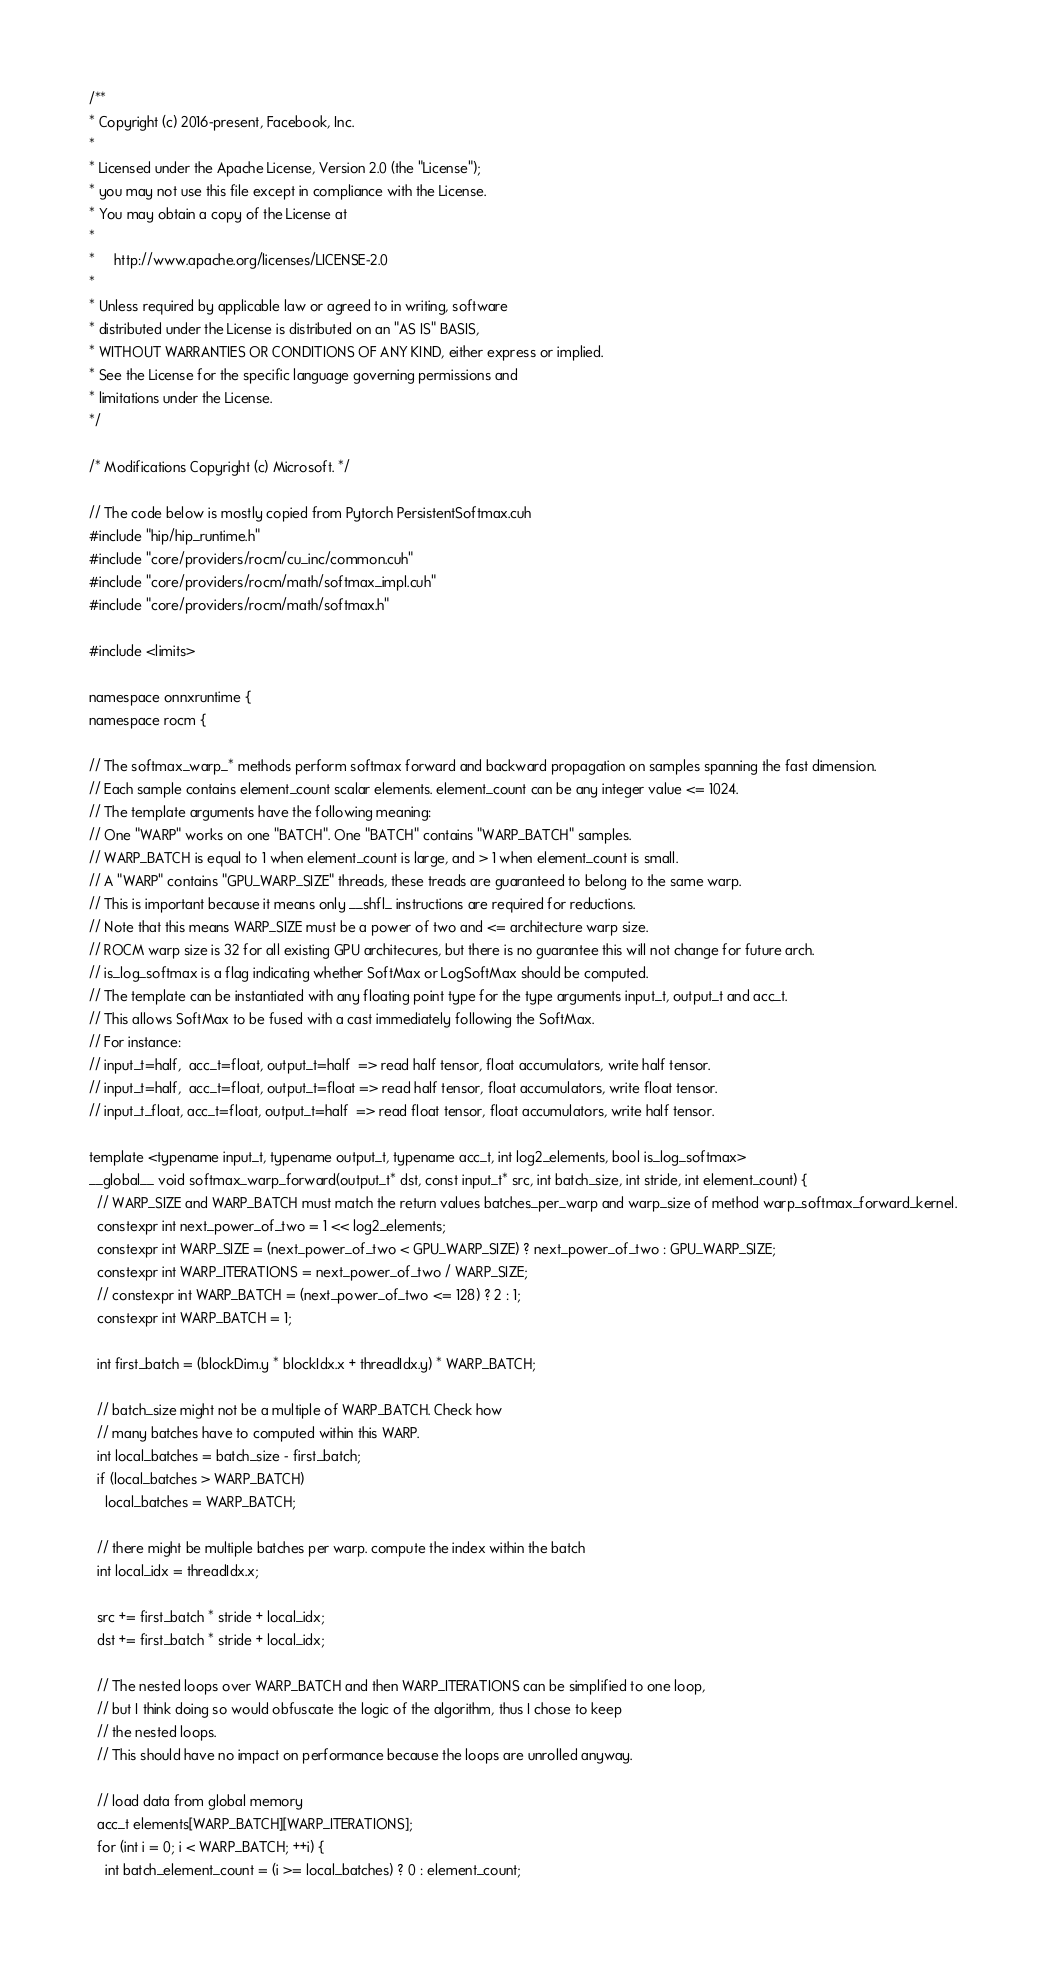<code> <loc_0><loc_0><loc_500><loc_500><_Cuda_>/**
* Copyright (c) 2016-present, Facebook, Inc.
*
* Licensed under the Apache License, Version 2.0 (the "License");
* you may not use this file except in compliance with the License.
* You may obtain a copy of the License at
*
*     http://www.apache.org/licenses/LICENSE-2.0
*
* Unless required by applicable law or agreed to in writing, software
* distributed under the License is distributed on an "AS IS" BASIS,
* WITHOUT WARRANTIES OR CONDITIONS OF ANY KIND, either express or implied.
* See the License for the specific language governing permissions and
* limitations under the License.
*/

/* Modifications Copyright (c) Microsoft. */

// The code below is mostly copied from Pytorch PersistentSoftmax.cuh
#include "hip/hip_runtime.h"
#include "core/providers/rocm/cu_inc/common.cuh"
#include "core/providers/rocm/math/softmax_impl.cuh"
#include "core/providers/rocm/math/softmax.h"

#include <limits>

namespace onnxruntime {
namespace rocm {

// The softmax_warp_* methods perform softmax forward and backward propagation on samples spanning the fast dimension.
// Each sample contains element_count scalar elements. element_count can be any integer value <= 1024.
// The template arguments have the following meaning:
// One "WARP" works on one "BATCH". One "BATCH" contains "WARP_BATCH" samples.
// WARP_BATCH is equal to 1 when element_count is large, and > 1 when element_count is small.
// A "WARP" contains "GPU_WARP_SIZE" threads, these treads are guaranteed to belong to the same warp.
// This is important because it means only __shfl_ instructions are required for reductions.
// Note that this means WARP_SIZE must be a power of two and <= architecture warp size.
// ROCM warp size is 32 for all existing GPU architecures, but there is no guarantee this will not change for future arch.
// is_log_softmax is a flag indicating whether SoftMax or LogSoftMax should be computed.
// The template can be instantiated with any floating point type for the type arguments input_t, output_t and acc_t.
// This allows SoftMax to be fused with a cast immediately following the SoftMax.
// For instance:
// input_t=half,  acc_t=float, output_t=half  => read half tensor, float accumulators, write half tensor.
// input_t=half,  acc_t=float, output_t=float => read half tensor, float accumulators, write float tensor.
// input_t_float, acc_t=float, output_t=half  => read float tensor, float accumulators, write half tensor.

template <typename input_t, typename output_t, typename acc_t, int log2_elements, bool is_log_softmax>
__global__ void softmax_warp_forward(output_t* dst, const input_t* src, int batch_size, int stride, int element_count) {
  // WARP_SIZE and WARP_BATCH must match the return values batches_per_warp and warp_size of method warp_softmax_forward_kernel.
  constexpr int next_power_of_two = 1 << log2_elements;
  constexpr int WARP_SIZE = (next_power_of_two < GPU_WARP_SIZE) ? next_power_of_two : GPU_WARP_SIZE;
  constexpr int WARP_ITERATIONS = next_power_of_two / WARP_SIZE;
  // constexpr int WARP_BATCH = (next_power_of_two <= 128) ? 2 : 1;
  constexpr int WARP_BATCH = 1;

  int first_batch = (blockDim.y * blockIdx.x + threadIdx.y) * WARP_BATCH;

  // batch_size might not be a multiple of WARP_BATCH. Check how
  // many batches have to computed within this WARP.
  int local_batches = batch_size - first_batch;
  if (local_batches > WARP_BATCH)
    local_batches = WARP_BATCH;

  // there might be multiple batches per warp. compute the index within the batch
  int local_idx = threadIdx.x;

  src += first_batch * stride + local_idx;
  dst += first_batch * stride + local_idx;

  // The nested loops over WARP_BATCH and then WARP_ITERATIONS can be simplified to one loop,
  // but I think doing so would obfuscate the logic of the algorithm, thus I chose to keep
  // the nested loops.
  // This should have no impact on performance because the loops are unrolled anyway.

  // load data from global memory
  acc_t elements[WARP_BATCH][WARP_ITERATIONS];
  for (int i = 0; i < WARP_BATCH; ++i) {
    int batch_element_count = (i >= local_batches) ? 0 : element_count;</code> 